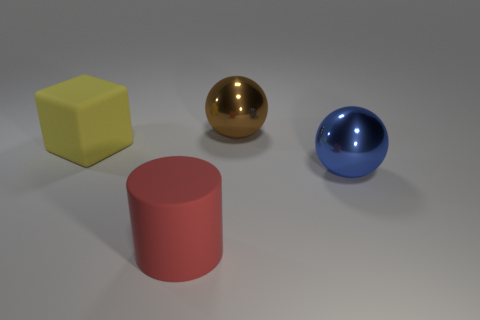What number of things are either large green rubber objects or big metallic spheres to the right of the brown thing?
Provide a short and direct response. 1. There is a big object that is behind the blue shiny thing and in front of the big brown shiny ball; what is its color?
Make the answer very short. Yellow. There is a big metal thing that is to the left of the blue ball; what is its color?
Provide a succinct answer. Brown. The rubber thing that is the same size as the red cylinder is what color?
Make the answer very short. Yellow. Do the large blue thing and the brown shiny object have the same shape?
Keep it short and to the point. Yes. What material is the blue object behind the red thing?
Your answer should be compact. Metal. What is the color of the big cube?
Ensure brevity in your answer.  Yellow. There is another object that is the same shape as the large brown object; what color is it?
Offer a very short reply. Blue. Is the number of rubber blocks that are in front of the big red rubber cylinder greater than the number of big blue objects behind the blue metal thing?
Your answer should be very brief. No. What number of other objects are the same shape as the big red thing?
Provide a short and direct response. 0. 